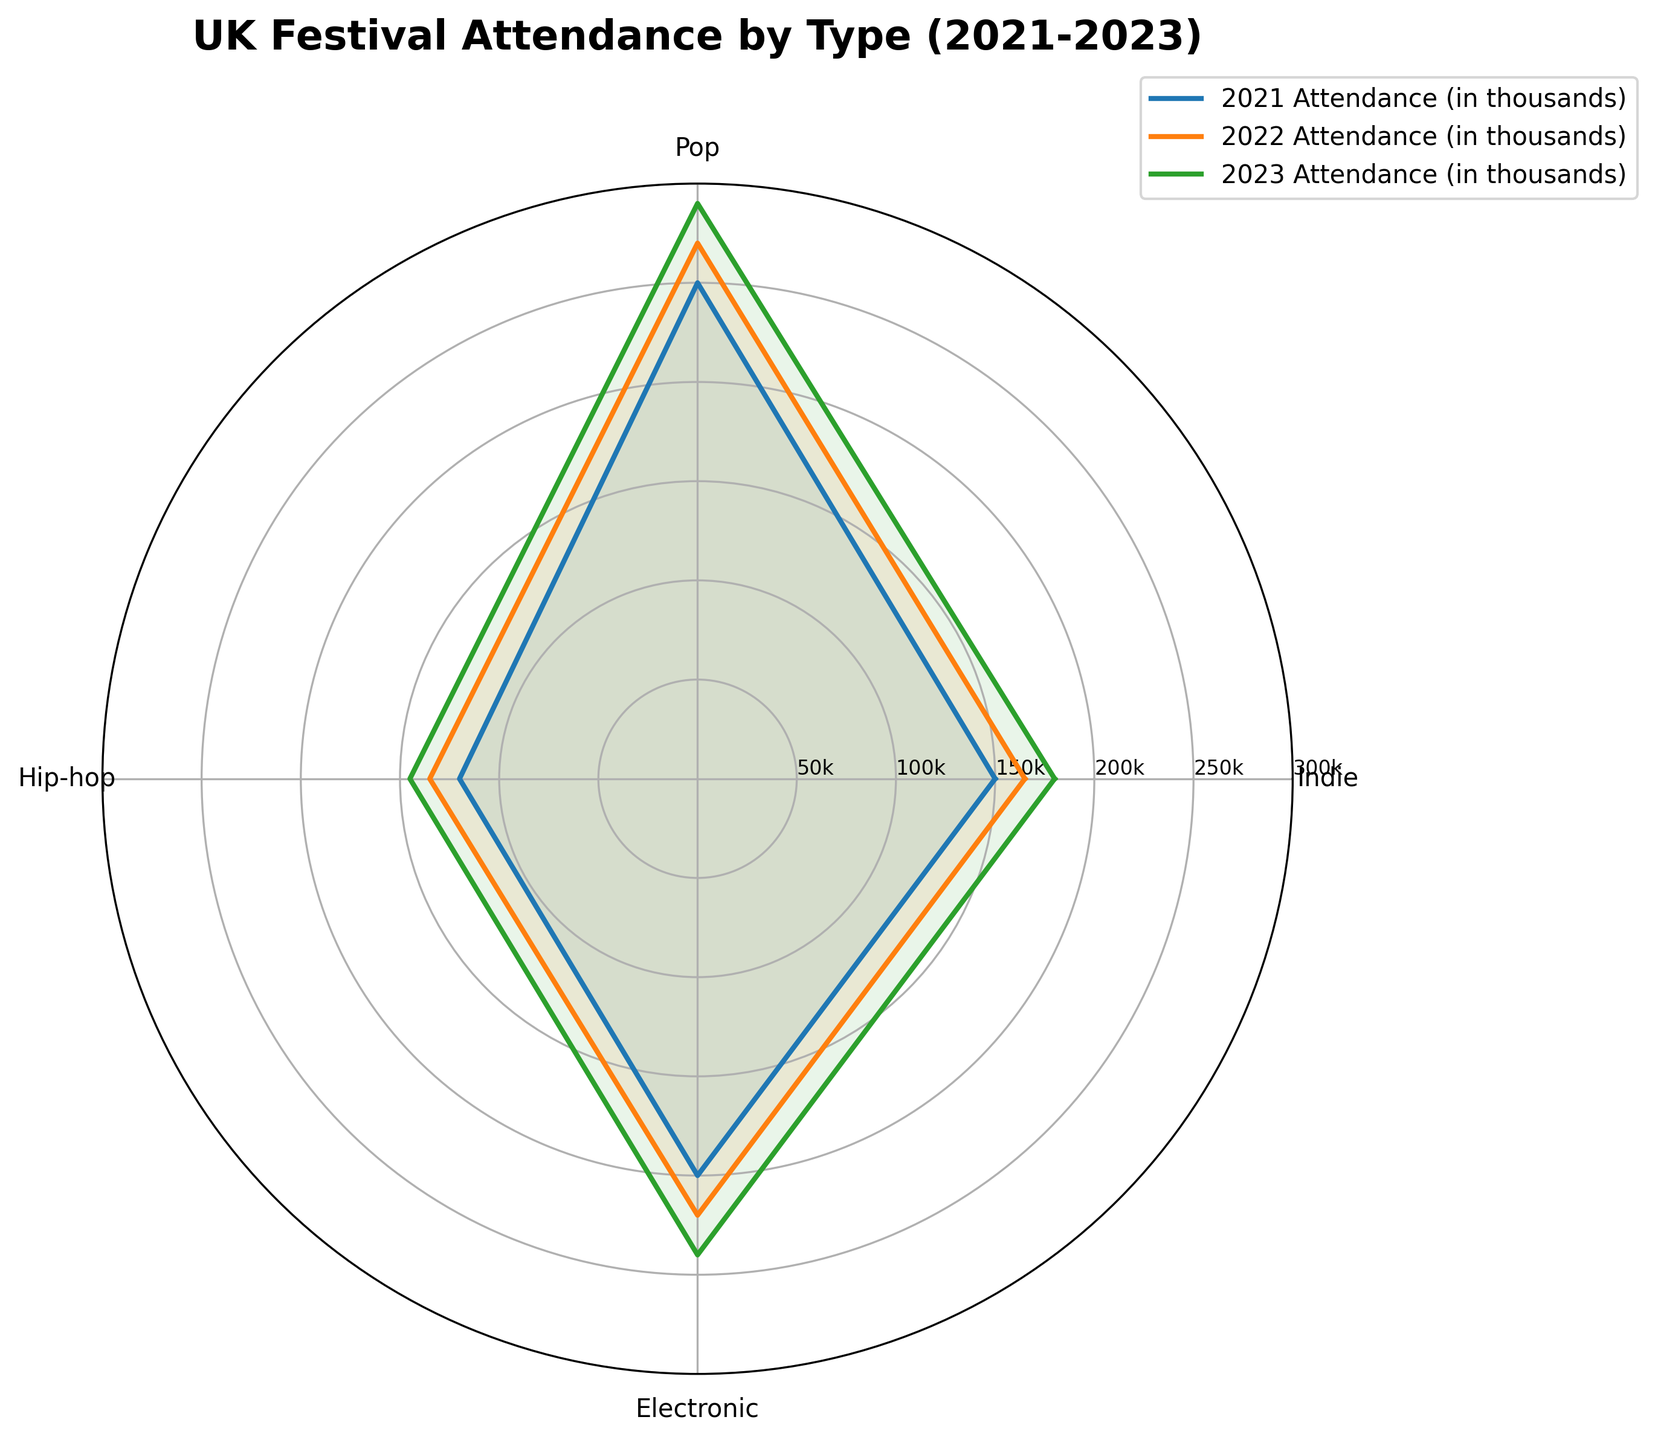What is the title of the figure? The title of the figure is written at the top, usually in a bold and larger font compared to other texts. It summarizes the chart's content.
Answer: UK Festival Attendance by Type (2021-2023) Which year had the highest attendance for Pop festivals? To determine the highest attendance, look at the curve corresponding to the Pop category on the radar chart and identify the point at the maximum distance from the center for each year. The outermost point will indicate the highest attendance.
Answer: 2023 What's the average attendance for Indie festivals across all three years? The attendance for Indie festivals are: 2021: 150, 2022: 165, 2023: 180. Sum these values (150+165+180=495) and then divide by the number of years (495/3 = 165).
Answer: 165 By how much did Electronic festival attendance increase from 2021 to 2023? Look at the Electronic category and find the values for 2021 and 2023. Subtract the 2021 value from the 2023 value to get the increase. 240 (2023) - 200 (2021) = 40.
Answer: 40 Compare the attendance growth of Hip-hop festivals from 2021 to 2022 and from 2022 to 2023. Which period saw greater growth? For Hip-hop, calculate the difference between 2021 and 2022 attendances (135-120=15) and between 2022 and 2023 attendances (145-135=10). Compare both differences: 15 (2021-2022) vs. 10 (2022-2023).
Answer: 2021 to 2022 Which festival type had the biggest increase in attendance from 2021 to 2023? Calculate the increase for each category: Indie (180-150), Pop (290-250), Hip-hop (145-120), and Electronic (240-200). The one with the highest increase is the largest: Indie=30, Pop=40, Hip-hop=25, Electronic=40.
Answer: Pop and Electronic (tie) What is the attendance difference between Indie and Hip-hop festivals in 2023? Look at the 2023 values for Indie and Hip-hop. Subtract the Hip-hop attendance from the Indie attendance: 180 (Indie) - 145 (Hip-hop) = 35.
Answer: 35 What trend can you observe for Electronic festival attendance over the three years? Examine the Electronic category points for all years. Notice that the values increase from the center outward consistently each year, indicating a rising trend.
Answer: Increasing trend Which year had the steepest rise in total festival attendance compared to 2021? First, add up the total attendance for each year: 
2021: 150 (Indie) + 250 (Pop) + 120 (Hip-hop) + 200 (Electronic) = 720, 
2022: 165 (Indie) + 270 (Pop) + 135 (Hip-hop) + 220 (Electronic) = 790,
2023: 180 (Indie) + 290 (Pop) + 145 (Hip-hop) + 240 (Electronic) = 855. 
Now, calculate the differences: 
2022-720 = 790-720 = 70,
2023-720 = 855-720 = 135.
The biggest difference is in 2023: 135.
Answer: 2023 In which year did Pop festivals always have the highest attendance among the festival types? Look at the Pop category for each year and compare its values with those of the other categories. Observe when Pop always had the highest attendance for all three years: 250 (2021), 270 (2022), 290 (2023). Pop is higher each year compared with other categories.
Answer: Every year (2021, 2022, 2023) 